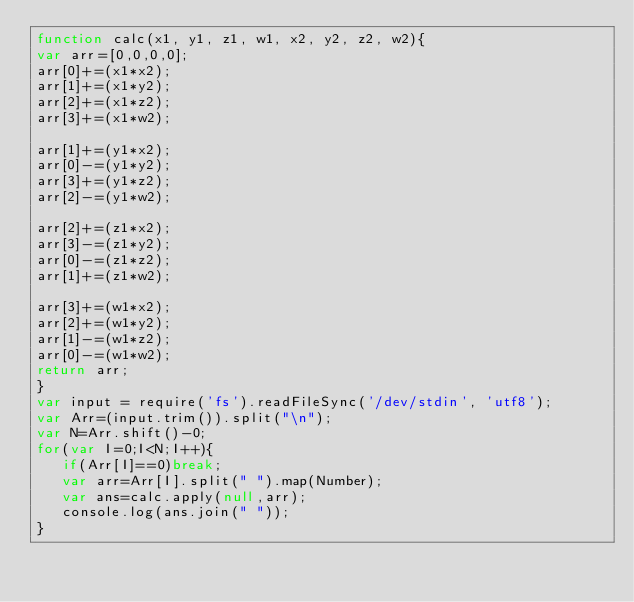<code> <loc_0><loc_0><loc_500><loc_500><_JavaScript_>function calc(x1, y1, z1, w1, x2, y2, z2, w2){ 
var arr=[0,0,0,0];
arr[0]+=(x1*x2);
arr[1]+=(x1*y2);
arr[2]+=(x1*z2);
arr[3]+=(x1*w2);

arr[1]+=(y1*x2);
arr[0]-=(y1*y2);
arr[3]+=(y1*z2);
arr[2]-=(y1*w2);

arr[2]+=(z1*x2);
arr[3]-=(z1*y2);
arr[0]-=(z1*z2);
arr[1]+=(z1*w2);

arr[3]+=(w1*x2);
arr[2]+=(w1*y2);
arr[1]-=(w1*z2);
arr[0]-=(w1*w2);
return arr;
}
var input = require('fs').readFileSync('/dev/stdin', 'utf8');
var Arr=(input.trim()).split("\n");
var N=Arr.shift()-0;
for(var I=0;I<N;I++){
   if(Arr[I]==0)break;
   var arr=Arr[I].split(" ").map(Number);
   var ans=calc.apply(null,arr);
   console.log(ans.join(" "));
}</code> 